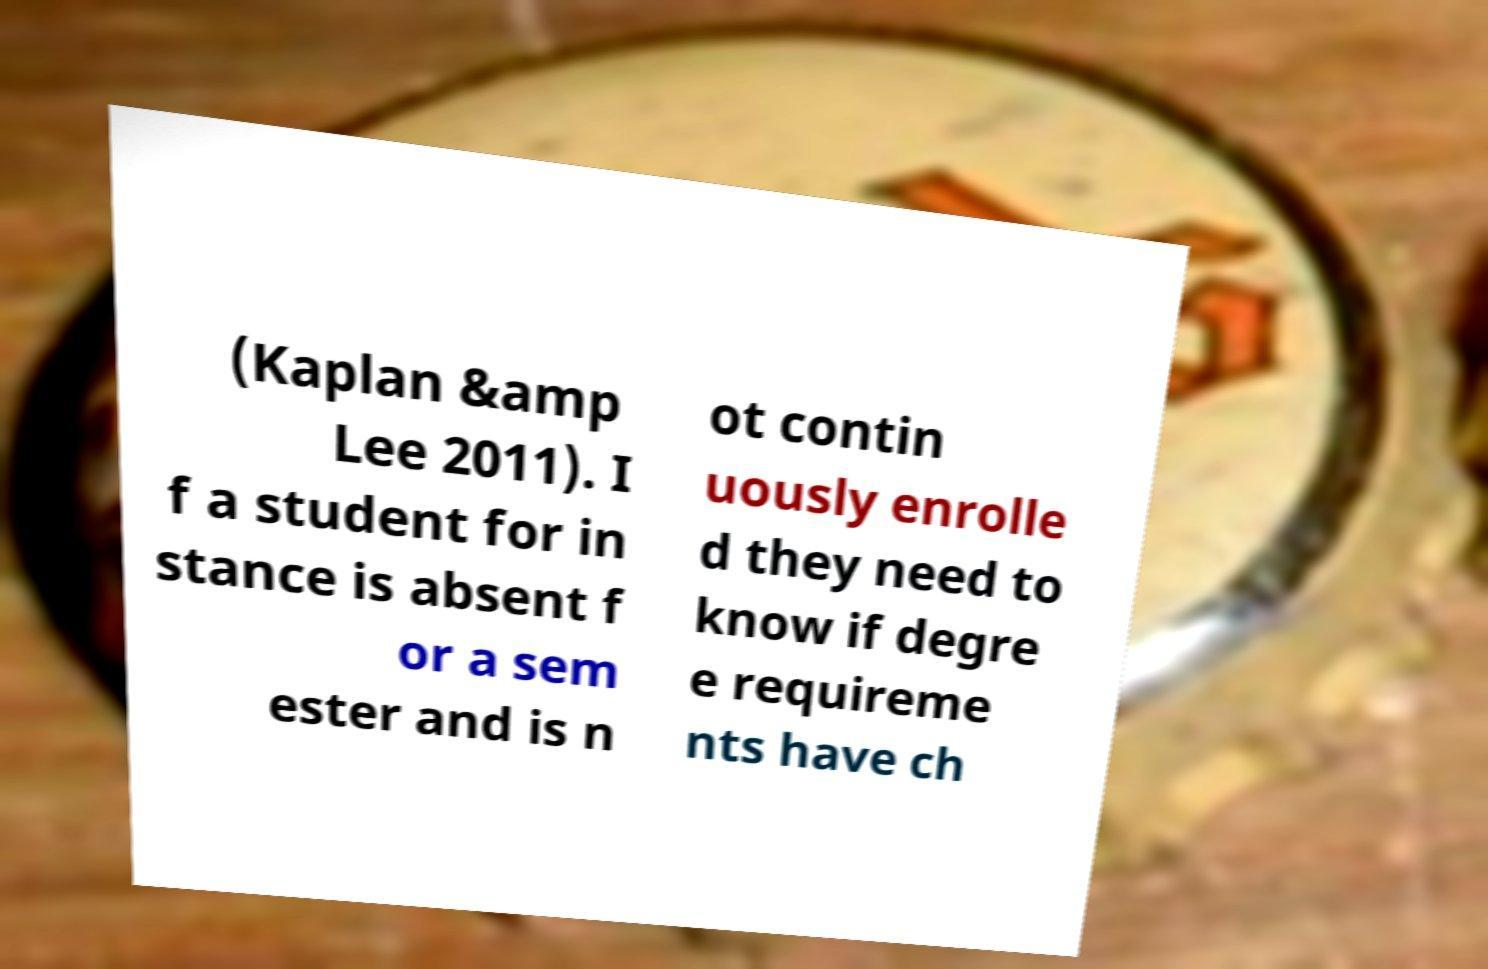Can you accurately transcribe the text from the provided image for me? (Kaplan &amp Lee 2011). I f a student for in stance is absent f or a sem ester and is n ot contin uously enrolle d they need to know if degre e requireme nts have ch 